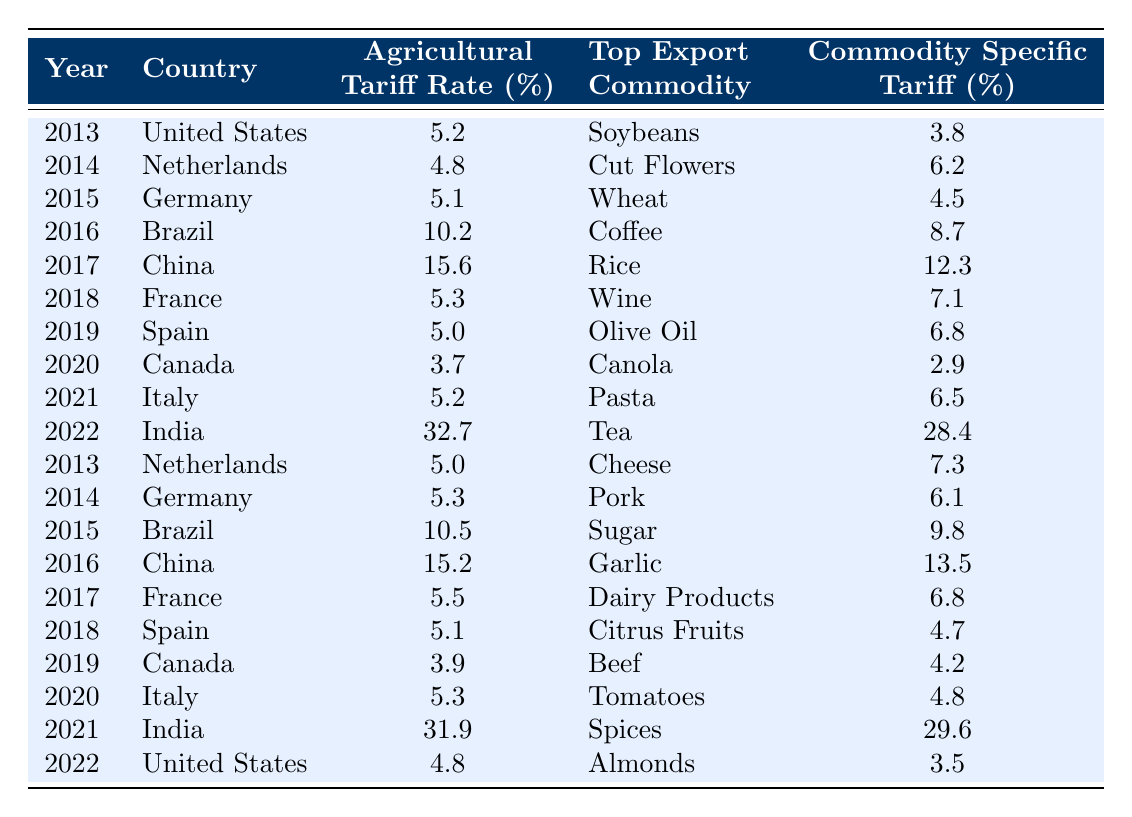What was the agricultural tariff rate for India in 2022? Looking at the table, under the year 2022 for the country India, the agricultural tariff rate is listed as 32.7%.
Answer: 32.7% Which country had the highest agricultural tariff rate in 2021? In 2021, the table shows India with a tariff rate of 31.9%, which is higher than the rates of other countries listed for the same year.
Answer: India What is the average agricultural tariff rate for the Netherlands over the years shown? The Dutch tariff rates are 4.8% (2014) and 5.0% (2013), and 5.1% (2018). Summing these gives 4.8 + 5.0 + 5.1 = 14.9%. Dividing by 3 gives 14.9/3 = 4.97%.
Answer: 4.97% Did the agricultural tariff rate for the United States decrease from 2013 to 2022? The table shows the rate for the United States as 5.2% in 2013 and 4.8% in 2022, indicating a decrease over this period.
Answer: Yes Which country consistently had tariff rates over 10% in the given years? Brazil and China had tariff rates over 10% consistently, with Brazil having rates of 10.2% (2016) and 10.5% (2015), while China had rates of 15.6% (2017) and 15.2% (2016).
Answer: Brazil and China What is the difference in the agricultural tariff rate between Canada in 2020 and Italy in 2021? The rate for Canada in 2020 is 3.7% and for Italy in 2021 is 5.2%. The difference is 5.2 - 3.7 = 1.5%.
Answer: 1.5% Which top export commodity had the highest commodity specific tariff rate in the shown data? India’s tea in 2022 has a specific tariff rate of 28.4%, which is the highest compared to the other commodities listed in the table.
Answer: Tea In which year did Spain have an agricultural tariff rate above 5%? The table lists Spain with a tariff rate of 5.1% in 2018 and 5.0% in 2019. Both rates are not above 5%, but 5.1% is close and is the only significant mention; so technically, only 5.1% in 2018 satisfies the condition.
Answer: 2018 What was the top export commodity of China in 2016? The table indicates that China’s top export commodity in 2016 was garlic.
Answer: Garlic How many countries had an agricultural tariff rate of 5% or less in the table? The countries with rates of 5% or less are Canada (3.7%, 2020 and 3.9%, 2019), and the Netherlands (4.8%, 2014 and 5.0%, 2013). Counting the unique instances gives us 4 instances less than or equal to 5%.
Answer: 4 